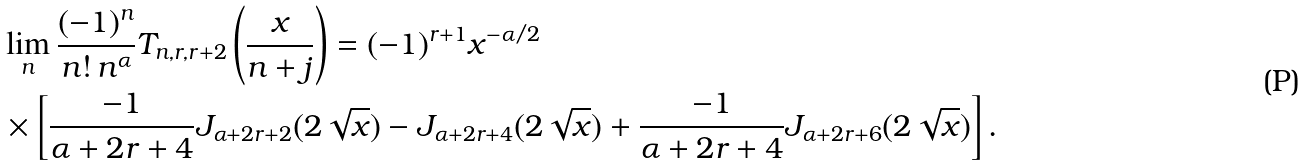Convert formula to latex. <formula><loc_0><loc_0><loc_500><loc_500>& \lim _ { n } \frac { ( - 1 ) ^ { n } } { n ! \, n ^ { \alpha } } T _ { n , r , r + 2 } \left ( \frac { x } { n + j } \right ) = ( - 1 ) ^ { r + 1 } x ^ { - \alpha / 2 } \\ & \times \left [ \frac { - 1 } { \alpha + 2 r + 4 } J _ { \alpha + 2 r + 2 } ( 2 \sqrt { x } ) - J _ { \alpha + 2 r + 4 } ( 2 \sqrt { x } ) + \frac { - 1 } { \alpha + 2 r + 4 } J _ { \alpha + 2 r + 6 } ( 2 \sqrt { x } ) \right ] .</formula> 